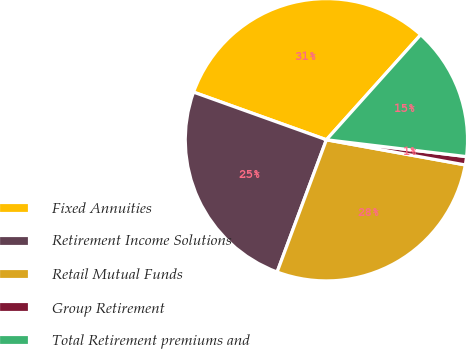<chart> <loc_0><loc_0><loc_500><loc_500><pie_chart><fcel>Fixed Annuities<fcel>Retirement Income Solutions<fcel>Retail Mutual Funds<fcel>Group Retirement<fcel>Total Retirement premiums and<nl><fcel>31.16%<fcel>24.8%<fcel>27.82%<fcel>0.95%<fcel>15.26%<nl></chart> 